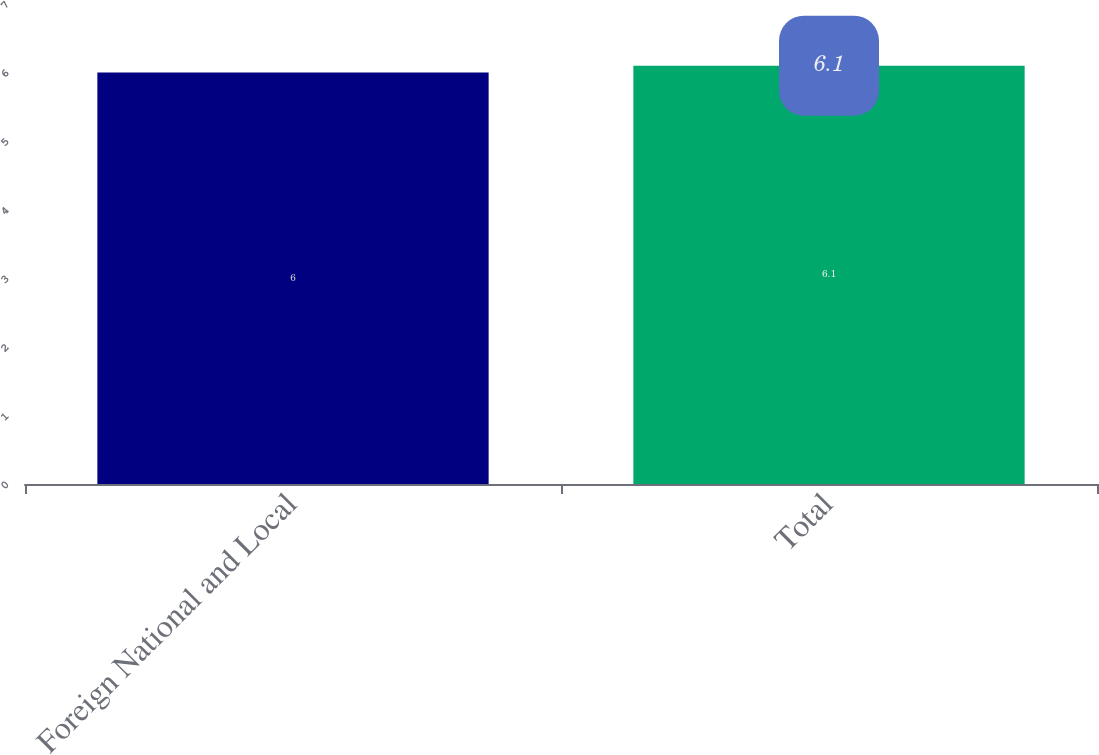Convert chart. <chart><loc_0><loc_0><loc_500><loc_500><bar_chart><fcel>Foreign National and Local<fcel>Total<nl><fcel>6<fcel>6.1<nl></chart> 